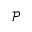<formula> <loc_0><loc_0><loc_500><loc_500>\mathcal { P }</formula> 